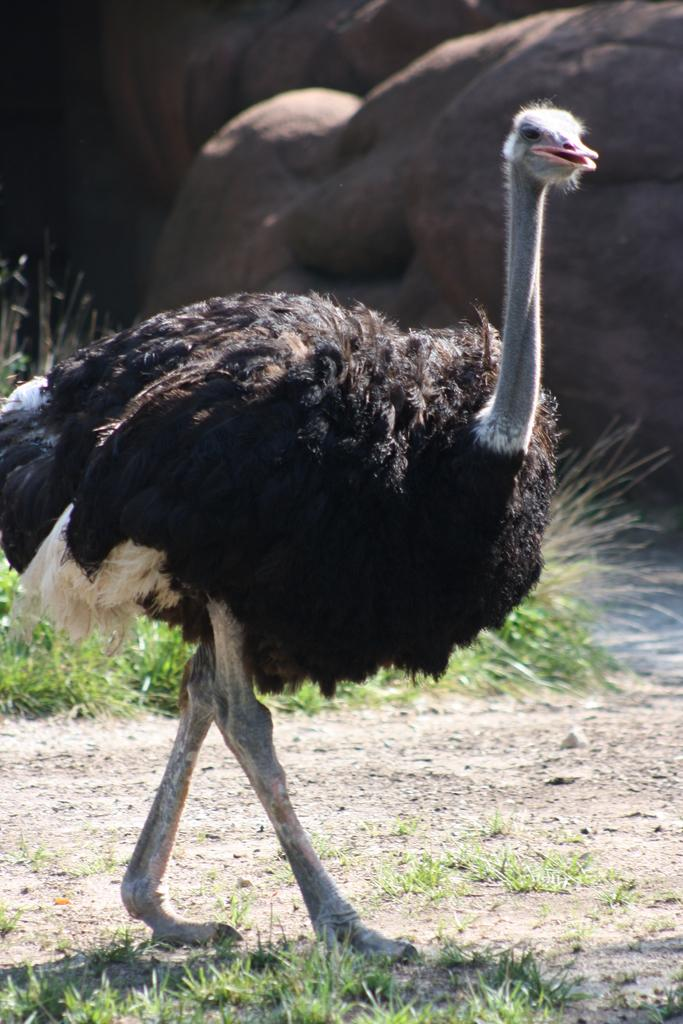What type of animal is in the image? There is an ostrich in the image. What can be seen in the background of the image? There is grass and rocks in the background of the image. What type of yak can be seen supporting the rocks in the image? There is no yak present in the image, and the rocks are not being supported by any animal. 